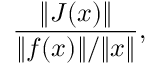<formula> <loc_0><loc_0><loc_500><loc_500>{ \frac { \| J ( x ) \| } { \| f ( x ) \| / \| x \| } } ,</formula> 